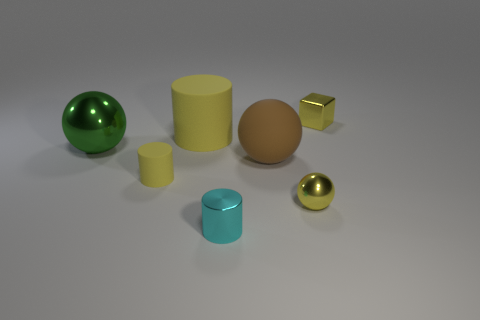Subtract all yellow cylinders. How many cylinders are left? 1 Add 2 yellow shiny things. How many objects exist? 9 Subtract 1 balls. How many balls are left? 2 Subtract all cylinders. How many objects are left? 4 Subtract all rubber spheres. Subtract all small gray metallic blocks. How many objects are left? 6 Add 6 large matte cylinders. How many large matte cylinders are left? 7 Add 6 tiny objects. How many tiny objects exist? 10 Subtract 1 cyan cylinders. How many objects are left? 6 